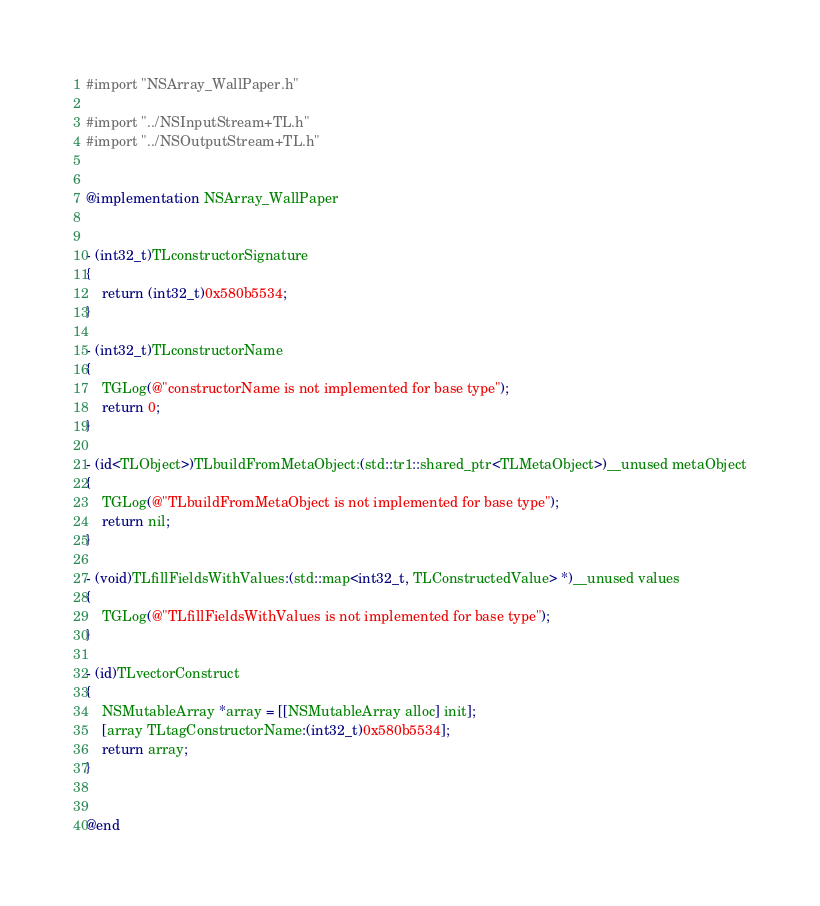<code> <loc_0><loc_0><loc_500><loc_500><_ObjectiveC_>#import "NSArray_WallPaper.h"

#import "../NSInputStream+TL.h"
#import "../NSOutputStream+TL.h"


@implementation NSArray_WallPaper


- (int32_t)TLconstructorSignature
{
    return (int32_t)0x580b5534;
}

- (int32_t)TLconstructorName
{
    TGLog(@"constructorName is not implemented for base type");
    return 0;
}

- (id<TLObject>)TLbuildFromMetaObject:(std::tr1::shared_ptr<TLMetaObject>)__unused metaObject
{
    TGLog(@"TLbuildFromMetaObject is not implemented for base type");
    return nil;
}

- (void)TLfillFieldsWithValues:(std::map<int32_t, TLConstructedValue> *)__unused values
{
    TGLog(@"TLfillFieldsWithValues is not implemented for base type");
}

- (id)TLvectorConstruct
{
    NSMutableArray *array = [[NSMutableArray alloc] init];
    [array TLtagConstructorName:(int32_t)0x580b5534];
    return array;
}


@end

</code> 